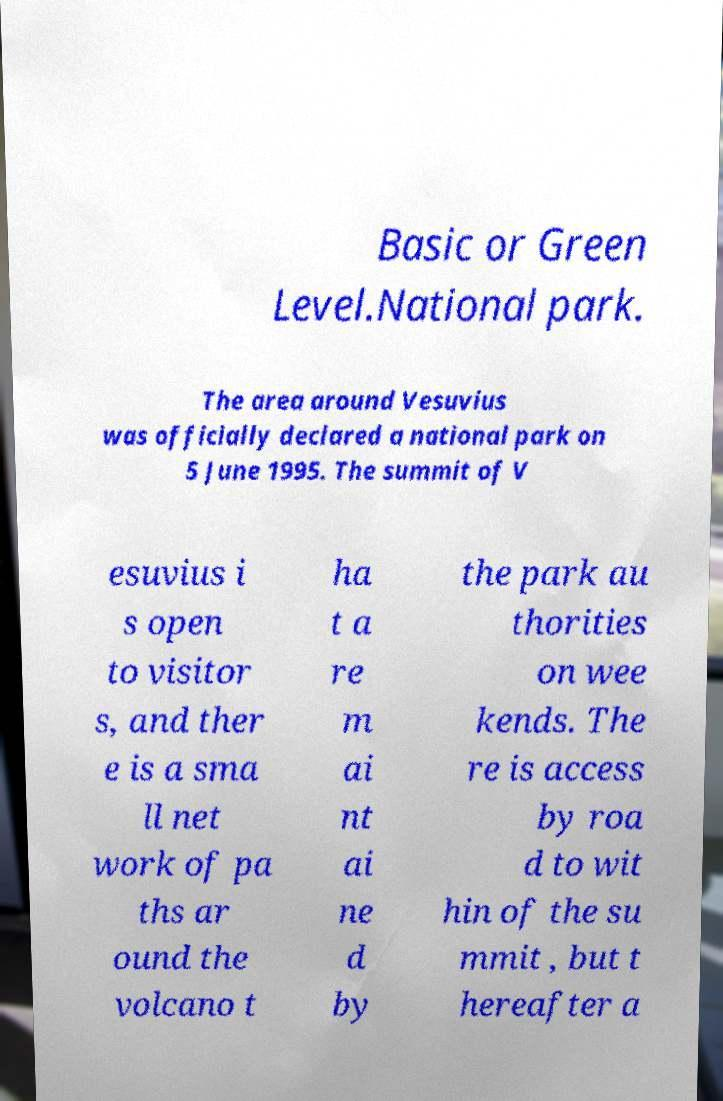Please identify and transcribe the text found in this image. Basic or Green Level.National park. The area around Vesuvius was officially declared a national park on 5 June 1995. The summit of V esuvius i s open to visitor s, and ther e is a sma ll net work of pa ths ar ound the volcano t ha t a re m ai nt ai ne d by the park au thorities on wee kends. The re is access by roa d to wit hin of the su mmit , but t hereafter a 